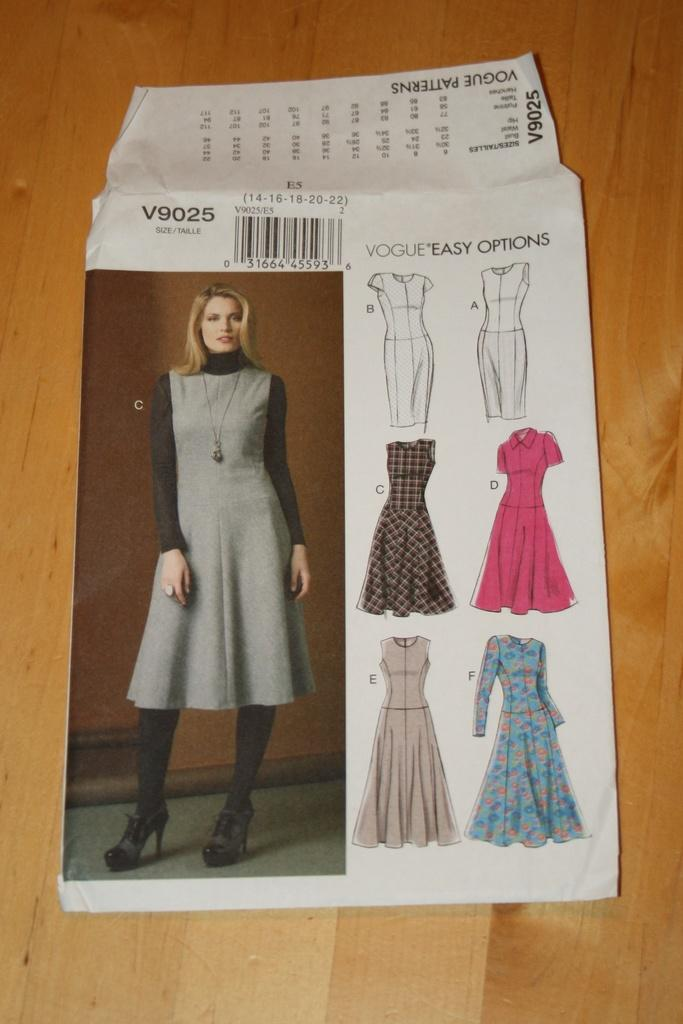What is featured on the poster in the image? The poster contains an image of a person and displays a few dresses. Is there any text on the poster? Yes, there is text on the poster. What type of object is located below the poster? There is a wooden object below the poster. What song is the baby singing while sitting in the carpenter's workshop in the image? There is no baby, song, or carpenter's workshop present in the image. 